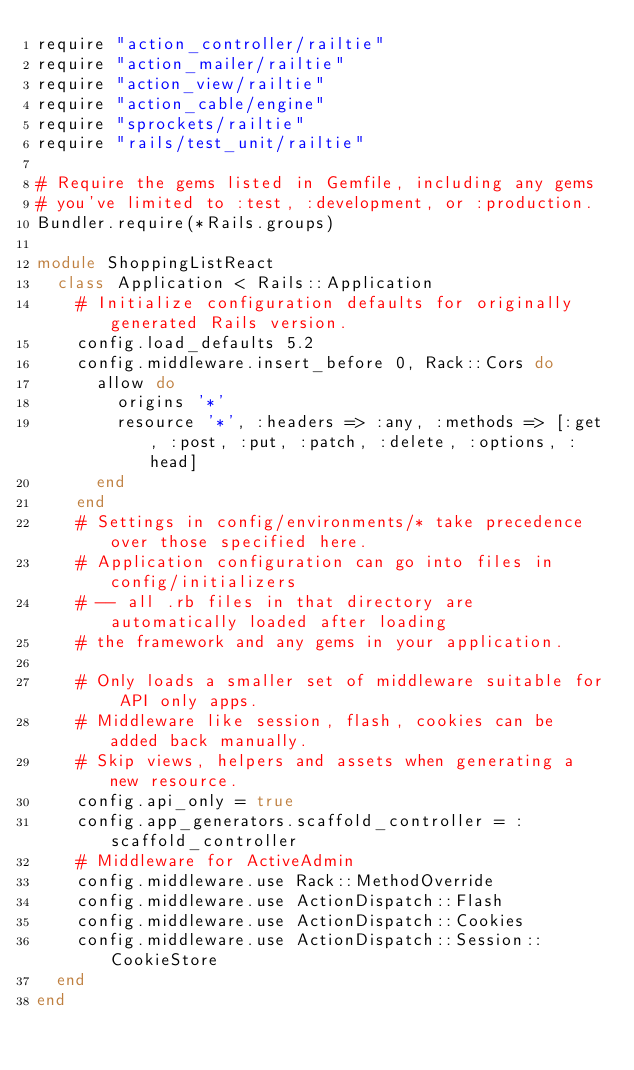Convert code to text. <code><loc_0><loc_0><loc_500><loc_500><_Ruby_>require "action_controller/railtie"
require "action_mailer/railtie"
require "action_view/railtie"
require "action_cable/engine"
require "sprockets/railtie"
require "rails/test_unit/railtie"

# Require the gems listed in Gemfile, including any gems
# you've limited to :test, :development, or :production.
Bundler.require(*Rails.groups)

module ShoppingListReact
  class Application < Rails::Application
    # Initialize configuration defaults for originally generated Rails version.
    config.load_defaults 5.2
    config.middleware.insert_before 0, Rack::Cors do
      allow do
        origins '*'
        resource '*', :headers => :any, :methods => [:get, :post, :put, :patch, :delete, :options, :head]
      end
    end
    # Settings in config/environments/* take precedence over those specified here.
    # Application configuration can go into files in config/initializers
    # -- all .rb files in that directory are automatically loaded after loading
    # the framework and any gems in your application.

    # Only loads a smaller set of middleware suitable for API only apps.
    # Middleware like session, flash, cookies can be added back manually.
    # Skip views, helpers and assets when generating a new resource.
    config.api_only = true
    config.app_generators.scaffold_controller = :scaffold_controller
    # Middleware for ActiveAdmin
    config.middleware.use Rack::MethodOverride
    config.middleware.use ActionDispatch::Flash
    config.middleware.use ActionDispatch::Cookies
    config.middleware.use ActionDispatch::Session::CookieStore
  end
end
</code> 